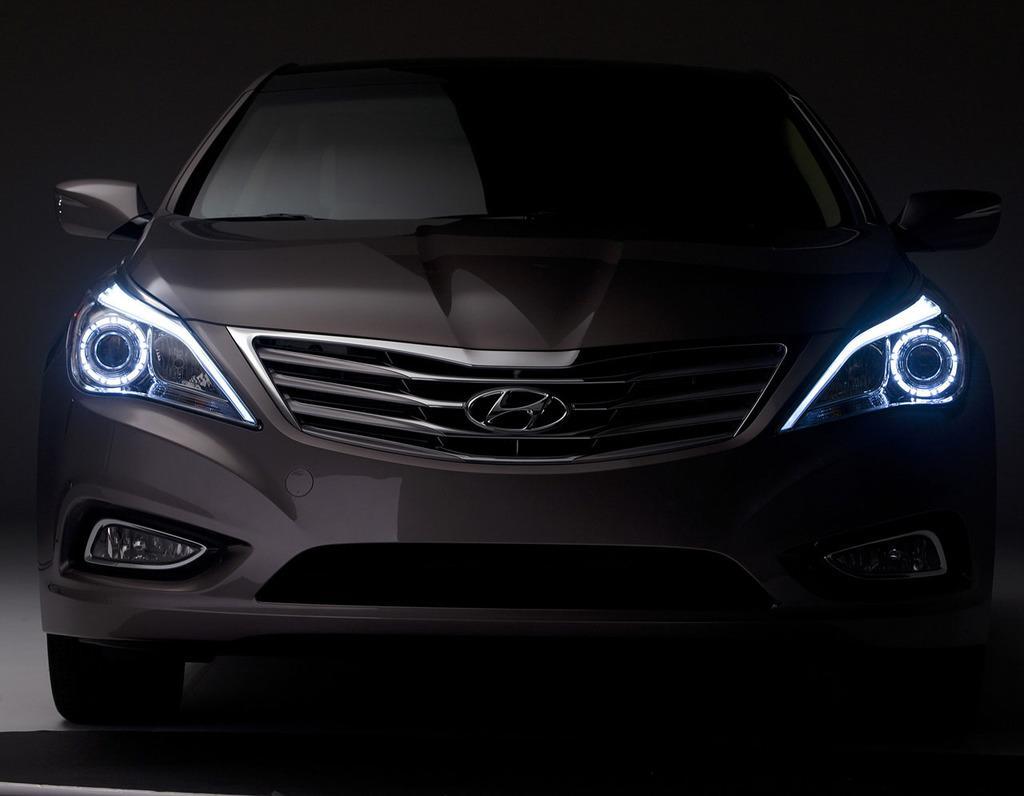Could you give a brief overview of what you see in this image? This is an image clicked in the dark. Here I can see a car on the floor. 